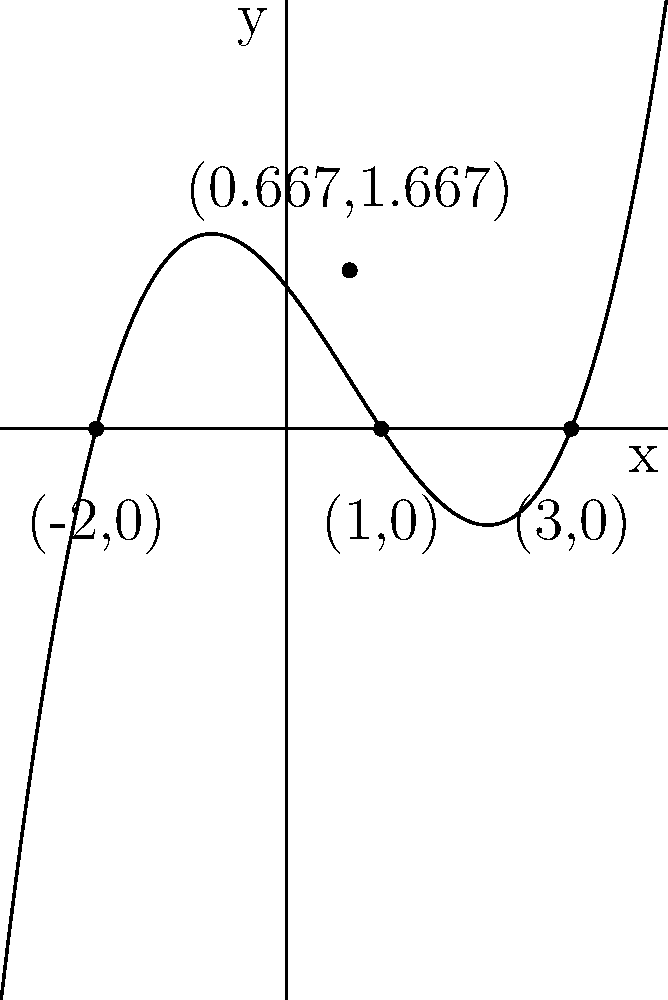As an IT specialist troubleshooting an e-commerce website's analytics dashboard, you encounter a graph representing sales data. The graph resembles a polynomial function in the form $f(x) = a(x+2)(x-1)(x-3)$, where $x$ represents time and $f(x)$ represents sales volume. Given the graph and the function's form, determine the value of $a$ and sketch the function. To solve this problem, we'll follow these steps:

1) First, we identify the roots of the polynomial from the given form:
   $f(x) = a(x+2)(x-1)(x-3)$
   Roots are at $x = -2$, $x = 1$, and $x = 3$

2) These roots correspond to the x-intercepts on the graph, which we can verify.

3) To find $a$, we need to use the given point that's not on the x-axis: (0.667, 1.667)

4) Substitute this point into the function:
   $1.667 = a(0.667+2)(0.667-1)(0.667-3)$
   $1.667 = a(2.667)(-0.333)(-2.333)$

5) Solve for $a$:
   $1.667 = a(-2.0677)$
   $a = -1.667 / 2.0677 \approx -0.806$

6) For simplicity, we can round this to $a = -0.8$ or $a = -\frac{4}{5}$

7) Therefore, the function is approximately:
   $f(x) = -0.8(x+2)(x-1)(x-3)$ or $f(x) = -\frac{4}{5}(x+2)(x-1)(x-3)$

8) To sketch the function:
   - Plot the x-intercepts at $x = -2$, $x = 1$, and $x = 3$
   - The y-intercept can be found by setting $x = 0$:
     $f(0) = -0.8(2)(-1)(-3) = 4.8$
   - The function is negative for $x < -2$ and $x > 3$, positive between $-2$ and $1$, and negative again between $1$ and $3$
   - The turning points are between each pair of roots

The resulting sketch should match the given graph.
Answer: $a \approx -0.8$ or $-\frac{4}{5}$; $f(x) \approx -0.8(x+2)(x-1)(x-3)$ 